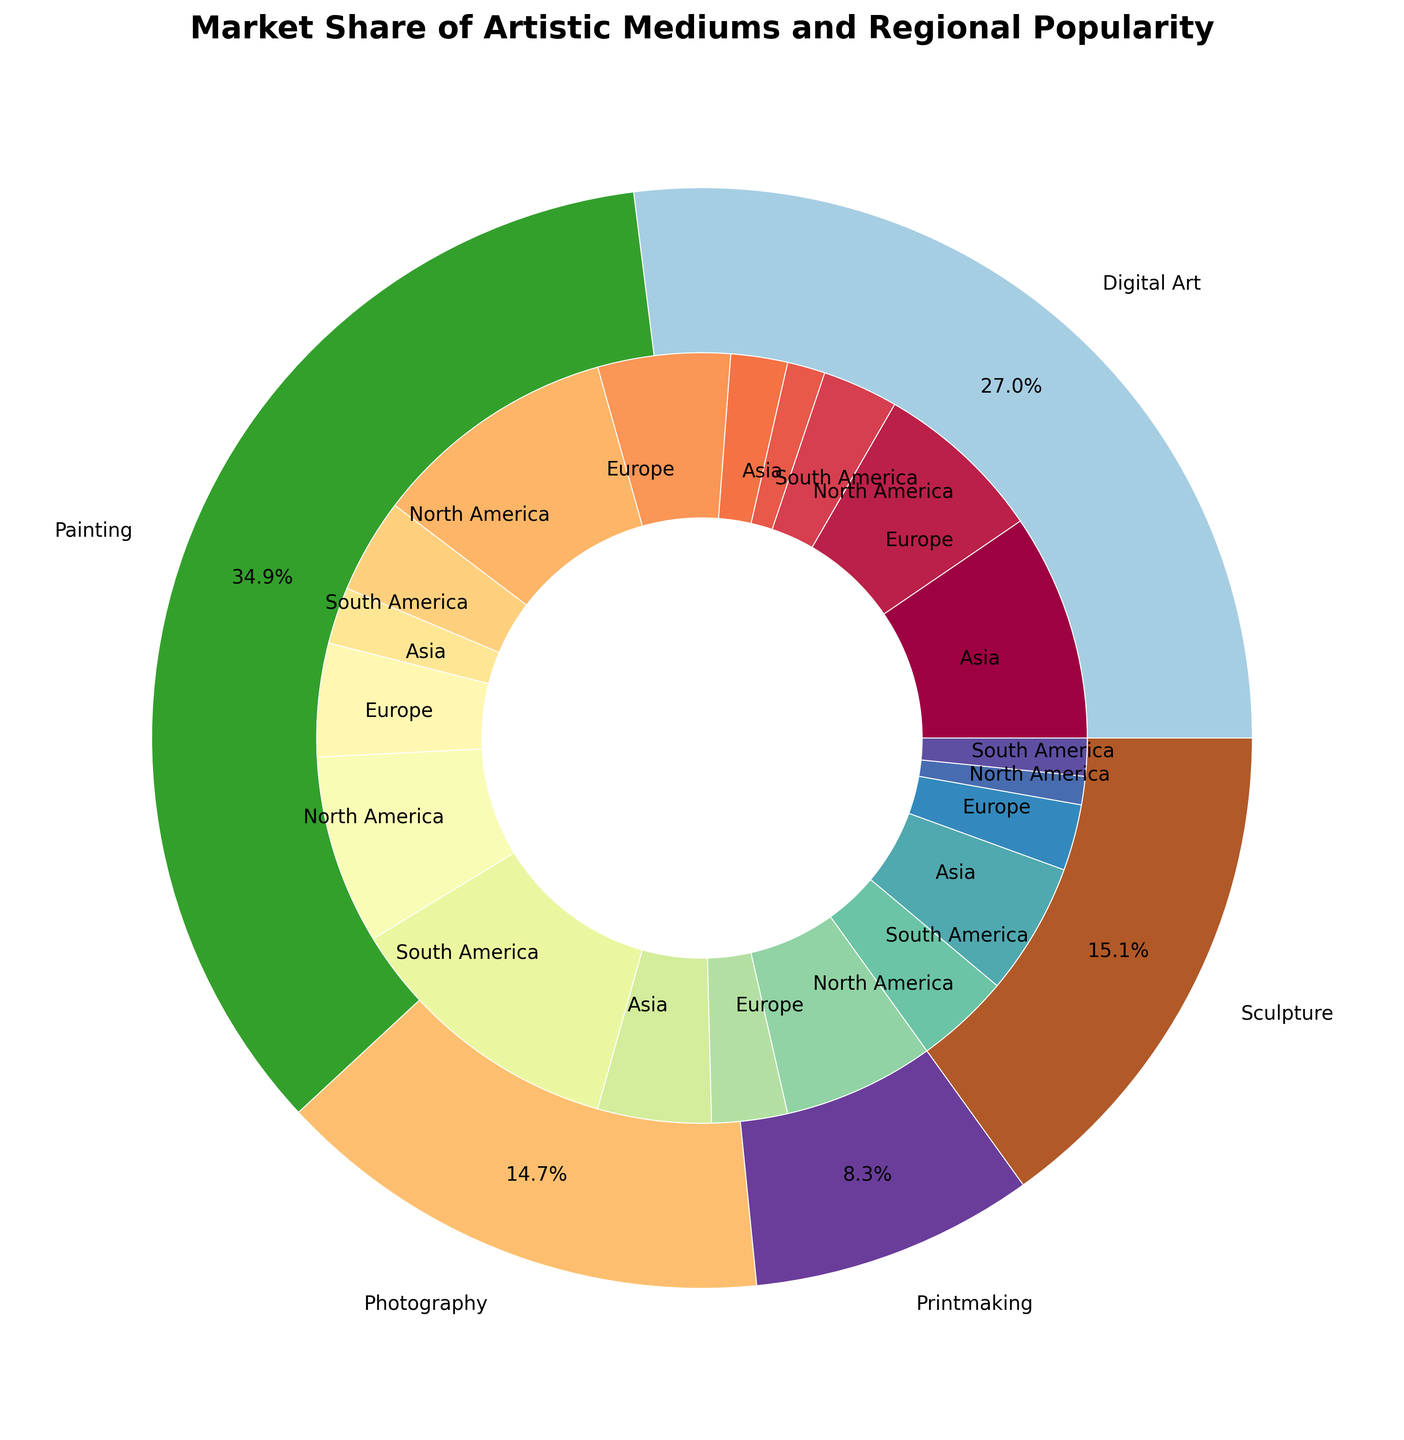What is the most popular artistic medium in terms of sales volume? To determine the most popular artistic medium, look at the outer pie chart and find the largest segment. The labels and percentages will help identify this.
Answer: Painting Which region has the highest sales volume for Digital Art? For this, look at the inner pie chart segment labelled Digital Art and check the regions composed within that segment. The segment with the highest percentage will represent the region with the largest sales volume for Digital Art.
Answer: Asia How do the total sales volumes of Sculpture and Digital Art compare? First, find the segments for Sculpture and Digital Art in the outer pie chart. Note their percentages. Since the sizes are visually represented and labelled, compare these values directly.
Answer: Digital Art has a higher sales volume than Sculpture Which region appears most frequently in the inner pie chart and what does this imply? Examine the inner pie chart segments to count how often each region (North America, Europe, Asia, South America) appears. The region that appears most frequently indicates it contributes to multiple mediums.
Answer: North America appears most frequently What is the combined sales volume for Paintings in North America and Europe? Look at the segments for Paintings in the inner pie chart, identify North America and Europe within that section, and sum their sales volumes (1500000 + 1300000).
Answer: 2800000 Which artistic medium shows the least regional variation in sales distribution? Look at the inner pie chart and examine the distribution of sales across regions for each medium. The medium with the most uniform segment sizes across regions has the least variation.
Answer: Printmaking How does the sales volume for Photography in South America compare to that in Asia? Locate the segments for Photography in the inner pie chart and identify South America and Asia. Compare their percentages or visual segment sizes.
Answer: Lower in South America than in Asia What is the difference between the total sales volumes of Painting and Sculpture in Europe? Find the sales volumes for Painting and Sculpture in the inner pie chart segments specific to Europe (1300000 for Painting and 600000 for Sculpture) and calculate the difference.
Answer: 700000 Which medium has the highest regional sales volume variance, and how is it determined? Look at the inner pie chart to analyze the sales distribution variances for each medium across different regions. The medium with the greatest difference between its highest and lowest regional sales figures shows the highest variance.
Answer: Digital Art What's the relative percentage of North American sales for Printmaking compared to its overall sales volume? Find the sales volume for Printmaking in North America and the total sales volume for Printmaking in the outer pie chart. Calculate the percentage (400000 / 1050000 * 100).
Answer: Approximately 38.1% 